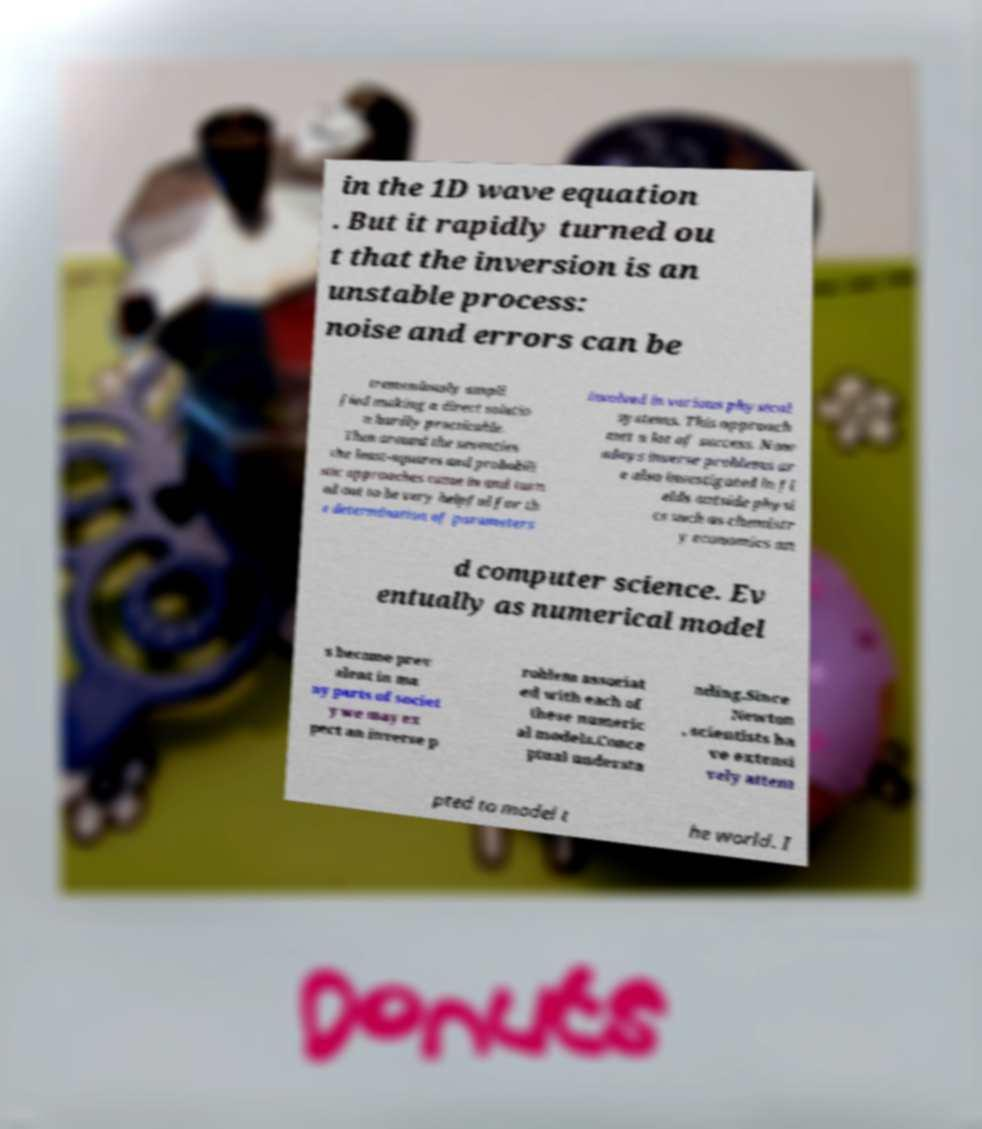Could you assist in decoding the text presented in this image and type it out clearly? in the 1D wave equation . But it rapidly turned ou t that the inversion is an unstable process: noise and errors can be tremendously ampli fied making a direct solutio n hardly practicable. Then around the seventies the least-squares and probabili stic approaches came in and turn ed out to be very helpful for th e determination of parameters involved in various physical systems. This approach met a lot of success. Now adays inverse problems ar e also investigated in fi elds outside physi cs such as chemistr y economics an d computer science. Ev entually as numerical model s become prev alent in ma ny parts of societ y we may ex pect an inverse p roblem associat ed with each of these numeric al models.Conce ptual understa nding.Since Newton , scientists ha ve extensi vely attem pted to model t he world. I 